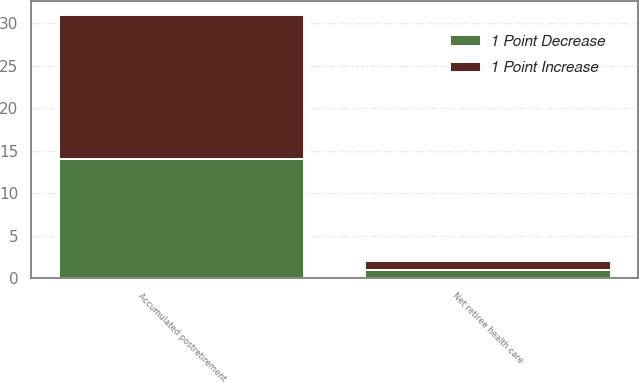Convert chart to OTSL. <chart><loc_0><loc_0><loc_500><loc_500><stacked_bar_chart><ecel><fcel>Accumulated postretirement<fcel>Net retiree health care<nl><fcel>1 Point Increase<fcel>17<fcel>1<nl><fcel>1 Point Decrease<fcel>14<fcel>1<nl></chart> 